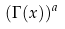Convert formula to latex. <formula><loc_0><loc_0><loc_500><loc_500>( \Gamma ( x ) ) ^ { a }</formula> 